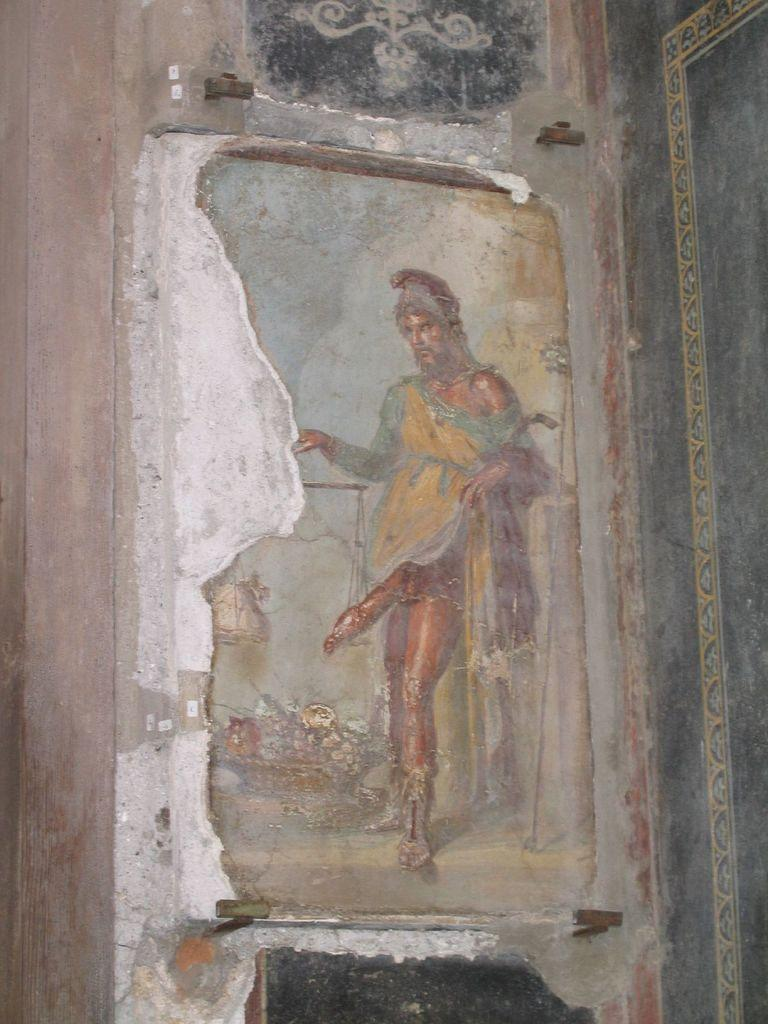What is depicted on the poster in the image? The poster is of a person. Where is the poster located in the image? The poster is on a wall. Can you tell me how many water bottles are on the plough in the image? There is no plough or water bottles present in the image; it only features a poster on a wall. 